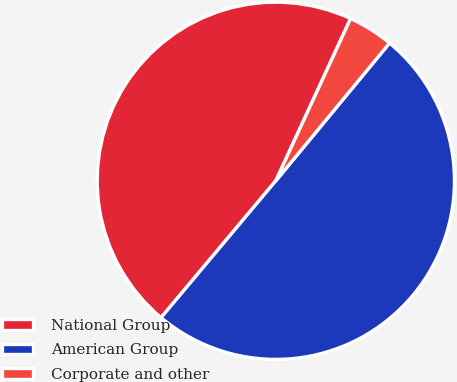<chart> <loc_0><loc_0><loc_500><loc_500><pie_chart><fcel>National Group<fcel>American Group<fcel>Corporate and other<nl><fcel>45.77%<fcel>50.12%<fcel>4.11%<nl></chart> 